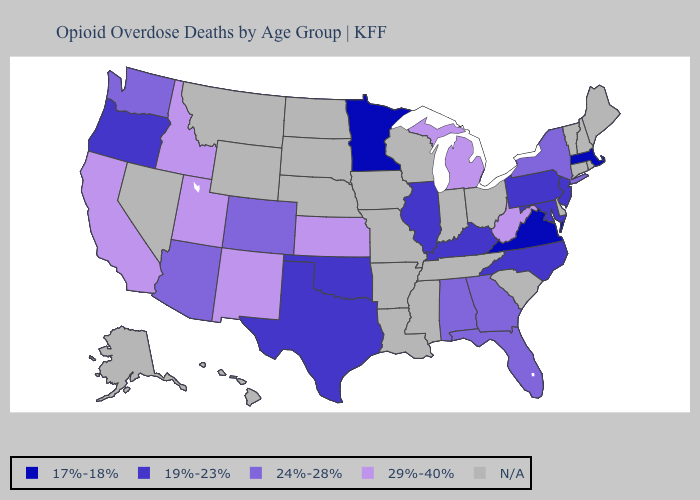What is the value of Wisconsin?
Write a very short answer. N/A. How many symbols are there in the legend?
Write a very short answer. 5. Which states hav the highest value in the West?
Answer briefly. California, Idaho, New Mexico, Utah. Name the states that have a value in the range 17%-18%?
Keep it brief. Massachusetts, Minnesota, Virginia. What is the value of Delaware?
Write a very short answer. N/A. What is the value of Michigan?
Answer briefly. 29%-40%. What is the lowest value in the USA?
Concise answer only. 17%-18%. Is the legend a continuous bar?
Answer briefly. No. Name the states that have a value in the range N/A?
Give a very brief answer. Alaska, Arkansas, Connecticut, Delaware, Hawaii, Indiana, Iowa, Louisiana, Maine, Mississippi, Missouri, Montana, Nebraska, Nevada, New Hampshire, North Dakota, Ohio, Rhode Island, South Carolina, South Dakota, Tennessee, Vermont, Wisconsin, Wyoming. Name the states that have a value in the range N/A?
Quick response, please. Alaska, Arkansas, Connecticut, Delaware, Hawaii, Indiana, Iowa, Louisiana, Maine, Mississippi, Missouri, Montana, Nebraska, Nevada, New Hampshire, North Dakota, Ohio, Rhode Island, South Carolina, South Dakota, Tennessee, Vermont, Wisconsin, Wyoming. Which states have the lowest value in the USA?
Quick response, please. Massachusetts, Minnesota, Virginia. Name the states that have a value in the range 17%-18%?
Write a very short answer. Massachusetts, Minnesota, Virginia. 